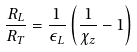Convert formula to latex. <formula><loc_0><loc_0><loc_500><loc_500>\frac { R _ { L } } { R _ { T } } = \frac { 1 } { \epsilon _ { L } } \left ( \frac { 1 } { \chi _ { z } } - 1 \right )</formula> 